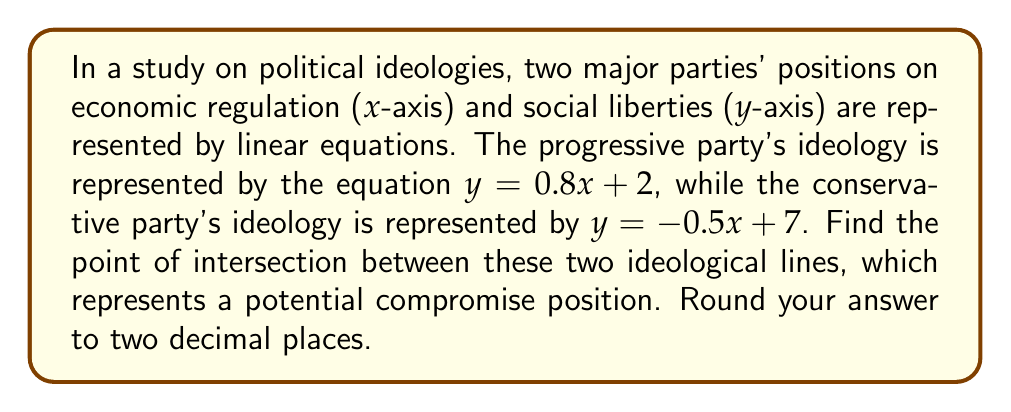Can you answer this question? To find the intersection point of two lines, we need to solve the system of equations:

$$\begin{cases}
y = 0.8x + 2 \\
y = -0.5x + 7
\end{cases}$$

Step 1: Set the equations equal to each other since they represent the same y-value at the intersection point.
$0.8x + 2 = -0.5x + 7$

Step 2: Solve for x by isolating variables on one side and constants on the other.
$0.8x + 0.5x = 7 - 2$
$1.3x = 5$

Step 3: Divide both sides by 1.3 to find x.
$x = \frac{5}{1.3} \approx 3.85$

Step 4: Substitute this x-value into either of the original equations to find y. Let's use the progressive party's equation:
$y = 0.8(3.85) + 2$
$y = 3.08 + 2 = 5.08$

Step 5: Round both x and y to two decimal places.
$x \approx 3.85$
$y \approx 5.08$

Therefore, the point of intersection is approximately (3.85, 5.08).
Answer: (3.85, 5.08) 